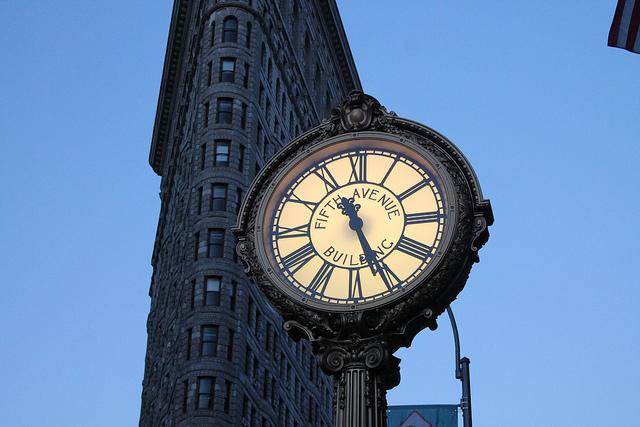This building is in what city?
Give a very brief answer. New york. What time is on the clock?
Answer briefly. 5:25. Is the clock illuminated?
Give a very brief answer. Yes. 